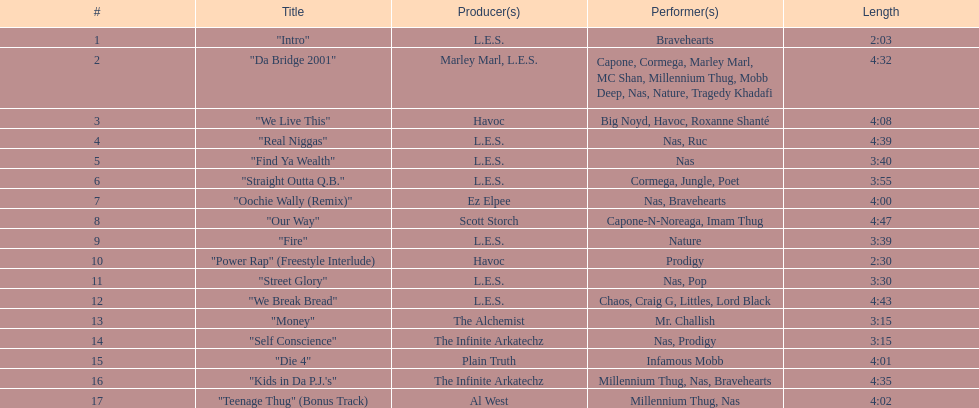What is the duration of the longest track on the list? 4:47. 